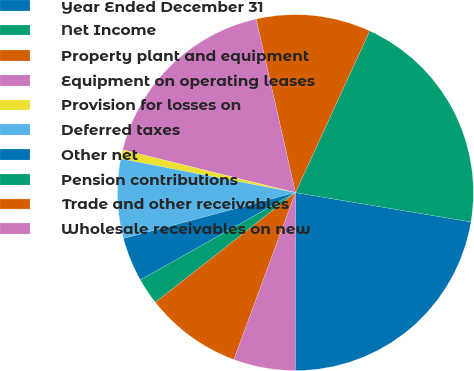Convert chart to OTSL. <chart><loc_0><loc_0><loc_500><loc_500><pie_chart><fcel>Year Ended December 31<fcel>Net Income<fcel>Property plant and equipment<fcel>Equipment on operating leases<fcel>Provision for losses on<fcel>Deferred taxes<fcel>Other net<fcel>Pension contributions<fcel>Trade and other receivables<fcel>Wholesale receivables on new<nl><fcel>22.38%<fcel>20.78%<fcel>10.4%<fcel>17.59%<fcel>0.82%<fcel>7.2%<fcel>4.01%<fcel>2.41%<fcel>8.8%<fcel>5.61%<nl></chart> 